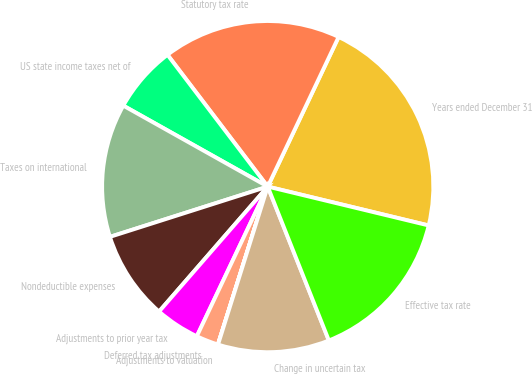<chart> <loc_0><loc_0><loc_500><loc_500><pie_chart><fcel>Years ended December 31<fcel>Statutory tax rate<fcel>US state income taxes net of<fcel>Taxes on international<fcel>Nondeductible expenses<fcel>Adjustments to prior year tax<fcel>Deferred tax adjustments<fcel>Adjustments to valuation<fcel>Change in uncertain tax<fcel>Effective tax rate<nl><fcel>21.73%<fcel>17.39%<fcel>6.52%<fcel>13.04%<fcel>8.7%<fcel>4.35%<fcel>2.18%<fcel>0.01%<fcel>10.87%<fcel>15.21%<nl></chart> 